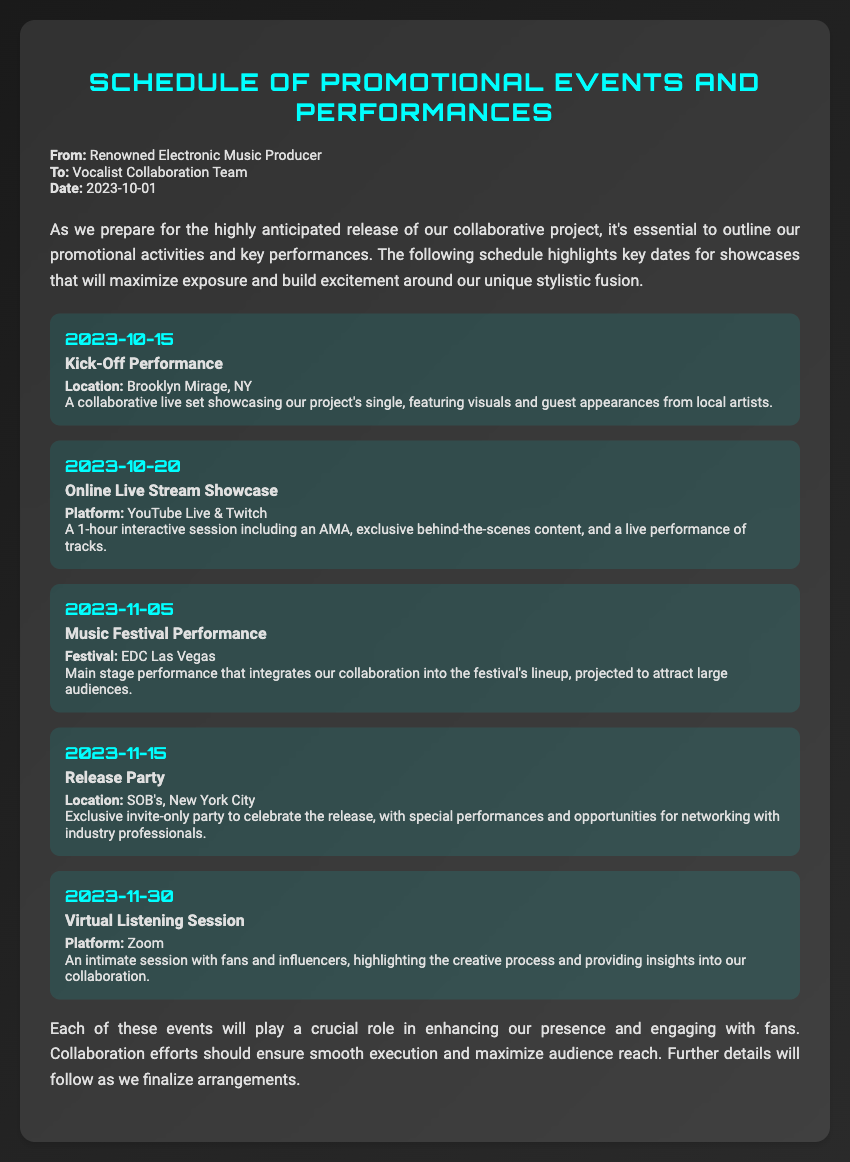What is the first event date? The first event listed in the document is the Kick-Off Performance, which is scheduled for 2023-10-15.
Answer: 2023-10-15 What is the location of the Release Party? The document specifies that the Release Party will be held at SOB's, New York City.
Answer: SOB's, New York City How many events are listed in the schedule? The schedule includes a total of five events, each with its own date and details.
Answer: 5 What type of showcase is on 2023-10-20? The event on that date is described as an Online Live Stream Showcase.
Answer: Online Live Stream Showcase What platform will host the Virtual Listening Session? The memo indicates that the Virtual Listening Session will occur on Zoom.
Answer: Zoom What is the main stage event during the music festival? The Music Festival Performance is the main stage event mentioned, integrating the collaboration.
Answer: Music Festival Performance Which performance integrates our collaboration into the festival's lineup? The Music Festival Performance at EDC Las Vegas integrates the collaboration into the lineup.
Answer: Music Festival Performance What will be featured at the Online Live Stream Showcase? The showcase will include an AMA, exclusive behind-the-scenes content, and a live performance of tracks.
Answer: AMA, exclusive behind-the-scenes content, live performance What is the purpose of the Release Party? The Release Party is an exclusive invite-only event to celebrate the release and network with industry professionals.
Answer: Celebrate the release and network with industry professionals 